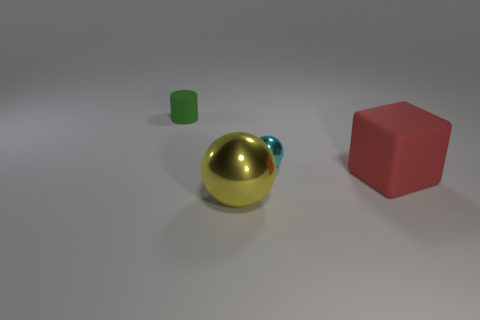There is another object that is the same size as the yellow shiny object; what material is it?
Provide a short and direct response. Rubber. Are there fewer large shiny things that are to the left of the red cube than metal balls that are in front of the large yellow metallic ball?
Make the answer very short. No. The object that is both on the right side of the yellow metal ball and on the left side of the large matte cube has what shape?
Ensure brevity in your answer.  Sphere. How many big red objects are the same shape as the cyan object?
Your response must be concise. 0. There is another sphere that is made of the same material as the cyan sphere; what size is it?
Provide a succinct answer. Large. Are there more brown shiny objects than objects?
Your response must be concise. No. What is the color of the metallic ball behind the red thing?
Provide a short and direct response. Cyan. There is a object that is both on the right side of the yellow metallic sphere and in front of the small cyan metal sphere; what is its size?
Your answer should be very brief. Large. What number of brown matte cubes are the same size as the red cube?
Offer a very short reply. 0. There is a cyan thing that is the same shape as the yellow object; what is it made of?
Your answer should be very brief. Metal. 